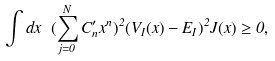<formula> <loc_0><loc_0><loc_500><loc_500>\int d x \ ( \sum _ { j = 0 } ^ { N } C _ { n } ^ { \prime } x ^ { n } ) ^ { 2 } ( V _ { I } ( x ) - E _ { I } ) ^ { 2 } J ( x ) \geq 0 ,</formula> 